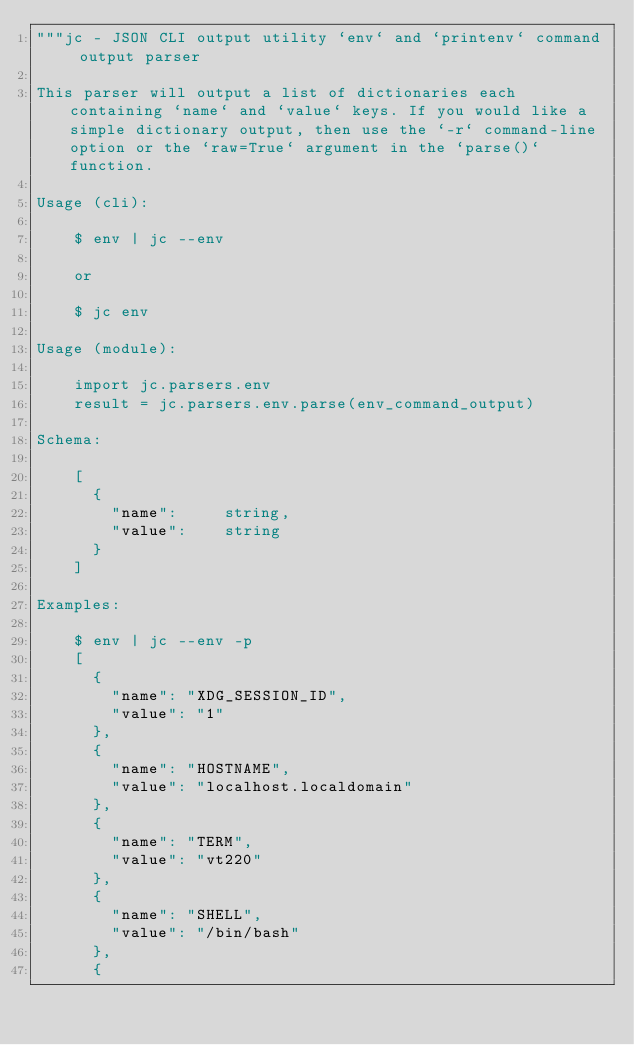Convert code to text. <code><loc_0><loc_0><loc_500><loc_500><_Python_>"""jc - JSON CLI output utility `env` and `printenv` command output parser

This parser will output a list of dictionaries each containing `name` and `value` keys. If you would like a simple dictionary output, then use the `-r` command-line option or the `raw=True` argument in the `parse()` function.

Usage (cli):

    $ env | jc --env

    or

    $ jc env

Usage (module):

    import jc.parsers.env
    result = jc.parsers.env.parse(env_command_output)

Schema:

    [
      {
        "name":     string,
        "value":    string
      }
    ]

Examples:

    $ env | jc --env -p
    [
      {
        "name": "XDG_SESSION_ID",
        "value": "1"
      },
      {
        "name": "HOSTNAME",
        "value": "localhost.localdomain"
      },
      {
        "name": "TERM",
        "value": "vt220"
      },
      {
        "name": "SHELL",
        "value": "/bin/bash"
      },
      {</code> 